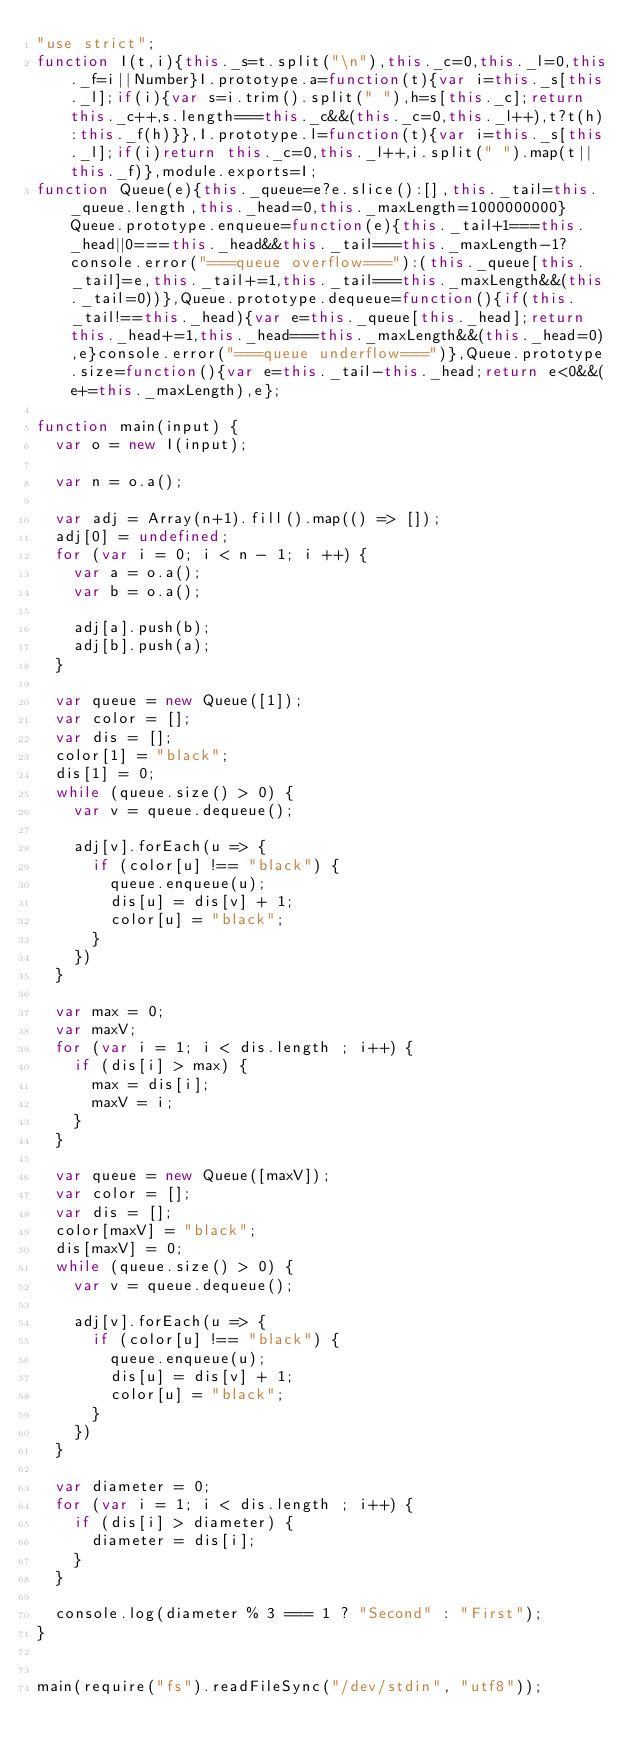Convert code to text. <code><loc_0><loc_0><loc_500><loc_500><_JavaScript_>"use strict";
function I(t,i){this._s=t.split("\n"),this._c=0,this._l=0,this._f=i||Number}I.prototype.a=function(t){var i=this._s[this._l];if(i){var s=i.trim().split(" "),h=s[this._c];return this._c++,s.length===this._c&&(this._c=0,this._l++),t?t(h):this._f(h)}},I.prototype.l=function(t){var i=this._s[this._l];if(i)return this._c=0,this._l++,i.split(" ").map(t||this._f)},module.exports=I;
function Queue(e){this._queue=e?e.slice():[],this._tail=this._queue.length,this._head=0,this._maxLength=1000000000}Queue.prototype.enqueue=function(e){this._tail+1===this._head||0===this._head&&this._tail===this._maxLength-1?console.error("===queue overflow==="):(this._queue[this._tail]=e,this._tail+=1,this._tail===this._maxLength&&(this._tail=0))},Queue.prototype.dequeue=function(){if(this._tail!==this._head){var e=this._queue[this._head];return this._head+=1,this._head===this._maxLength&&(this._head=0),e}console.error("===queue underflow===")},Queue.prototype.size=function(){var e=this._tail-this._head;return e<0&&(e+=this._maxLength),e};

function main(input) {
  var o = new I(input);

  var n = o.a();

  var adj = Array(n+1).fill().map(() => []);
  adj[0] = undefined;
  for (var i = 0; i < n - 1; i ++) {
    var a = o.a();
    var b = o.a();

    adj[a].push(b);
    adj[b].push(a);
  }

  var queue = new Queue([1]);
  var color = [];
  var dis = [];
  color[1] = "black";
  dis[1] = 0;
  while (queue.size() > 0) {
    var v = queue.dequeue();

    adj[v].forEach(u => {
      if (color[u] !== "black") {
        queue.enqueue(u);
        dis[u] = dis[v] + 1;
        color[u] = "black";
      }
    })
  }

  var max = 0;
  var maxV;
  for (var i = 1; i < dis.length ; i++) {
    if (dis[i] > max) {
      max = dis[i];
      maxV = i;
    }
  }

  var queue = new Queue([maxV]);
  var color = [];
  var dis = [];
  color[maxV] = "black";
  dis[maxV] = 0;
  while (queue.size() > 0) {
    var v = queue.dequeue();

    adj[v].forEach(u => {
      if (color[u] !== "black") {
        queue.enqueue(u);
        dis[u] = dis[v] + 1;
        color[u] = "black";
      }
    })
  }

  var diameter = 0;
  for (var i = 1; i < dis.length ; i++) {
    if (dis[i] > diameter) {
      diameter = dis[i];
    }
  }

  console.log(diameter % 3 === 1 ? "Second" : "First");
}


main(require("fs").readFileSync("/dev/stdin", "utf8"));
</code> 